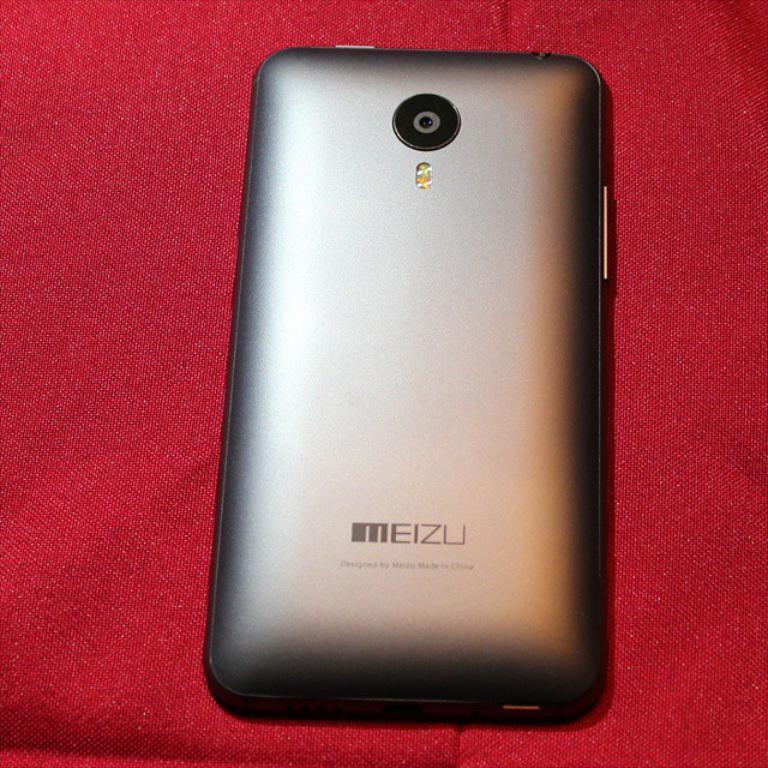What company name is found on this phone?
Your answer should be very brief. Meizu. 